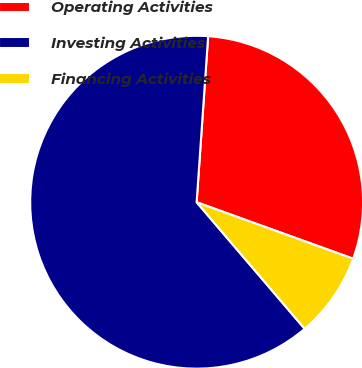Convert chart to OTSL. <chart><loc_0><loc_0><loc_500><loc_500><pie_chart><fcel>Operating Activities<fcel>Investing Activities<fcel>Financing Activities<nl><fcel>29.41%<fcel>62.35%<fcel>8.24%<nl></chart> 